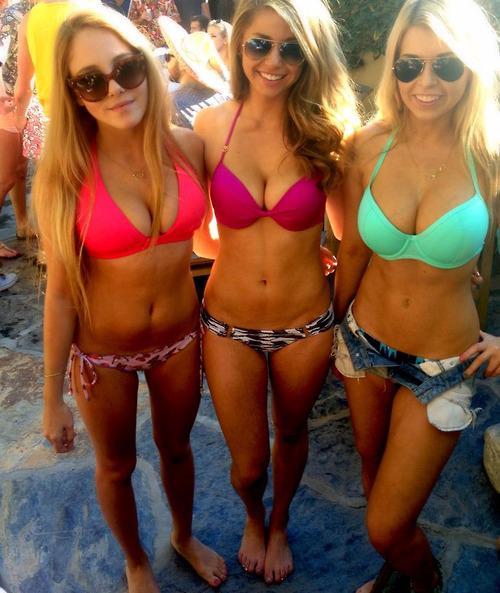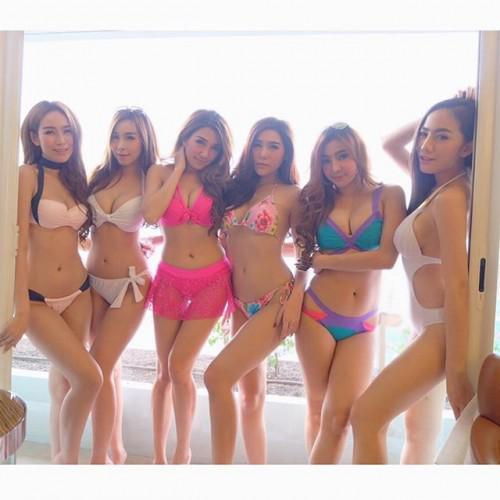The first image is the image on the left, the second image is the image on the right. Considering the images on both sides, is "At least 2 girls are wearing sunglasses." valid? Answer yes or no. Yes. The first image is the image on the left, the second image is the image on the right. For the images shown, is this caption "The women in the image on the right are standing at least up to their knees in the water." true? Answer yes or no. No. 